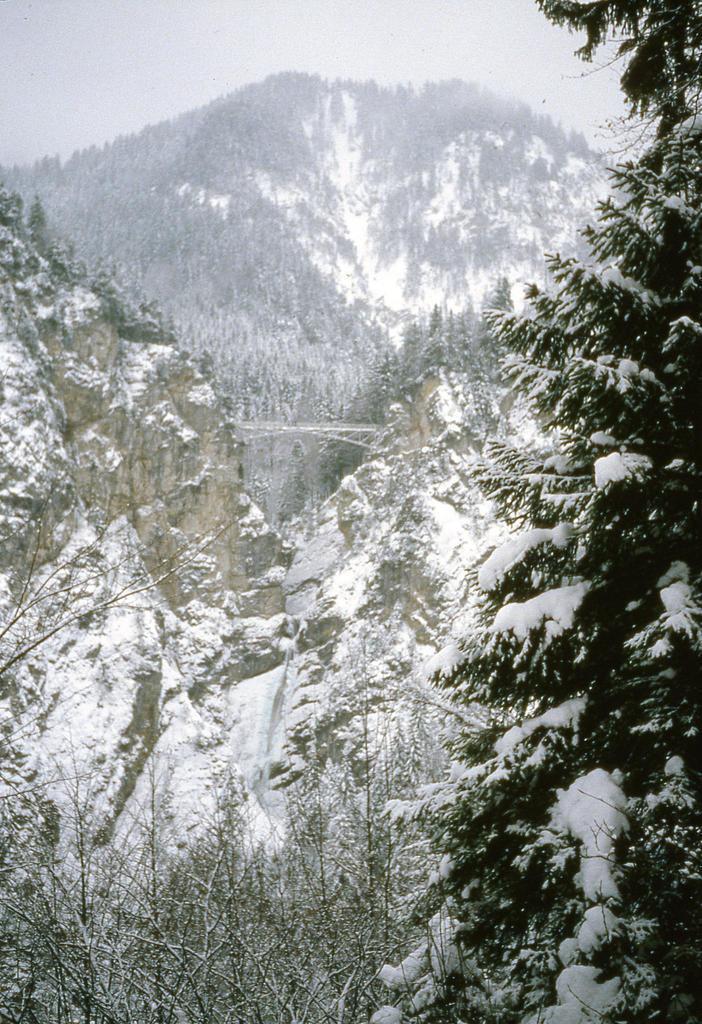Please provide a concise description of this image. In this image there are mountains which are covered with the snow. On the right side there is a tree which is covered with the snow. At the bottom there are small plants. 